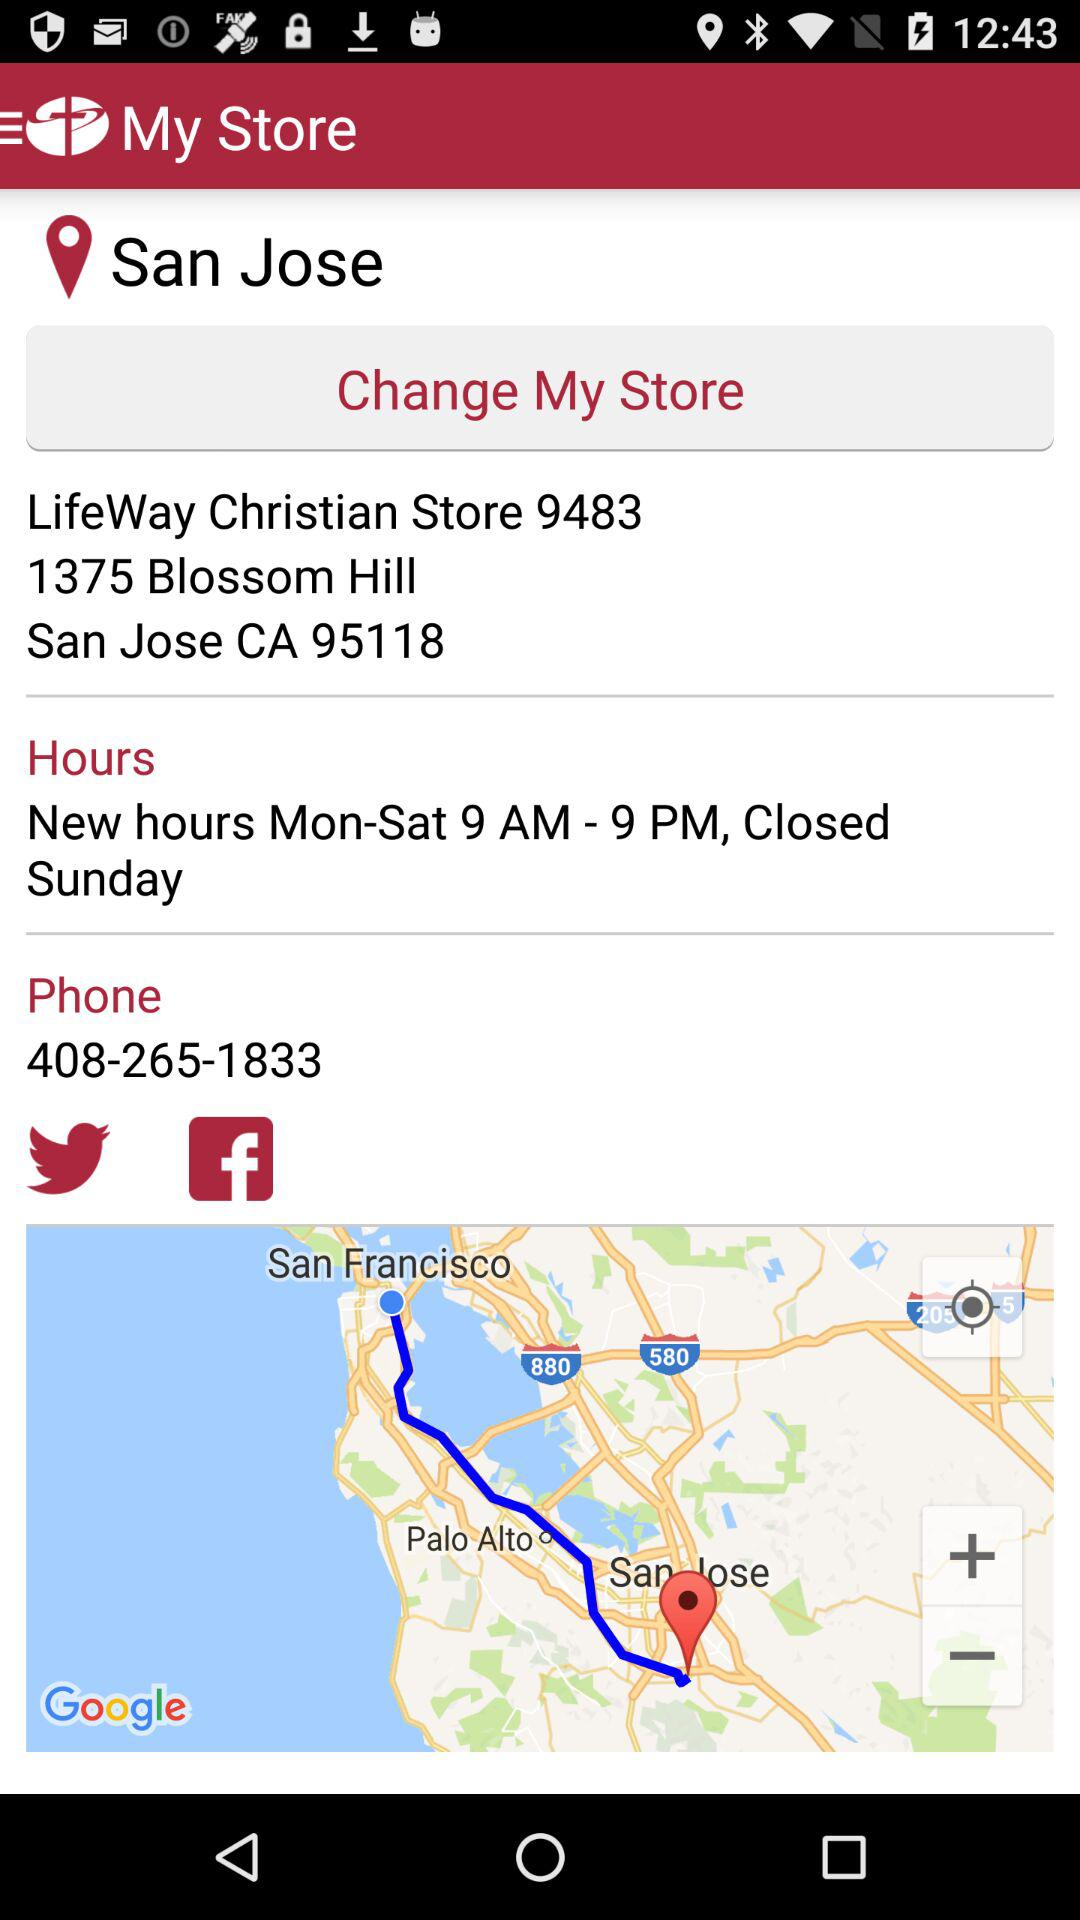What are the new hours for opening the store? The new hours for opening the store are Monday to Saturday from 9 AM to 9 PM. 